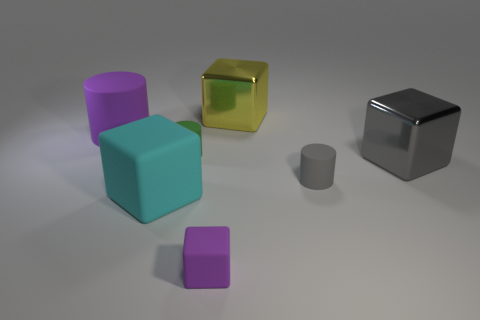Subtract 1 cubes. How many cubes are left? 3 Add 2 cyan shiny balls. How many objects exist? 9 Subtract all cubes. How many objects are left? 3 Subtract 0 blue cylinders. How many objects are left? 7 Subtract all yellow cubes. Subtract all yellow cubes. How many objects are left? 5 Add 1 gray metallic objects. How many gray metallic objects are left? 2 Add 5 yellow metal blocks. How many yellow metal blocks exist? 6 